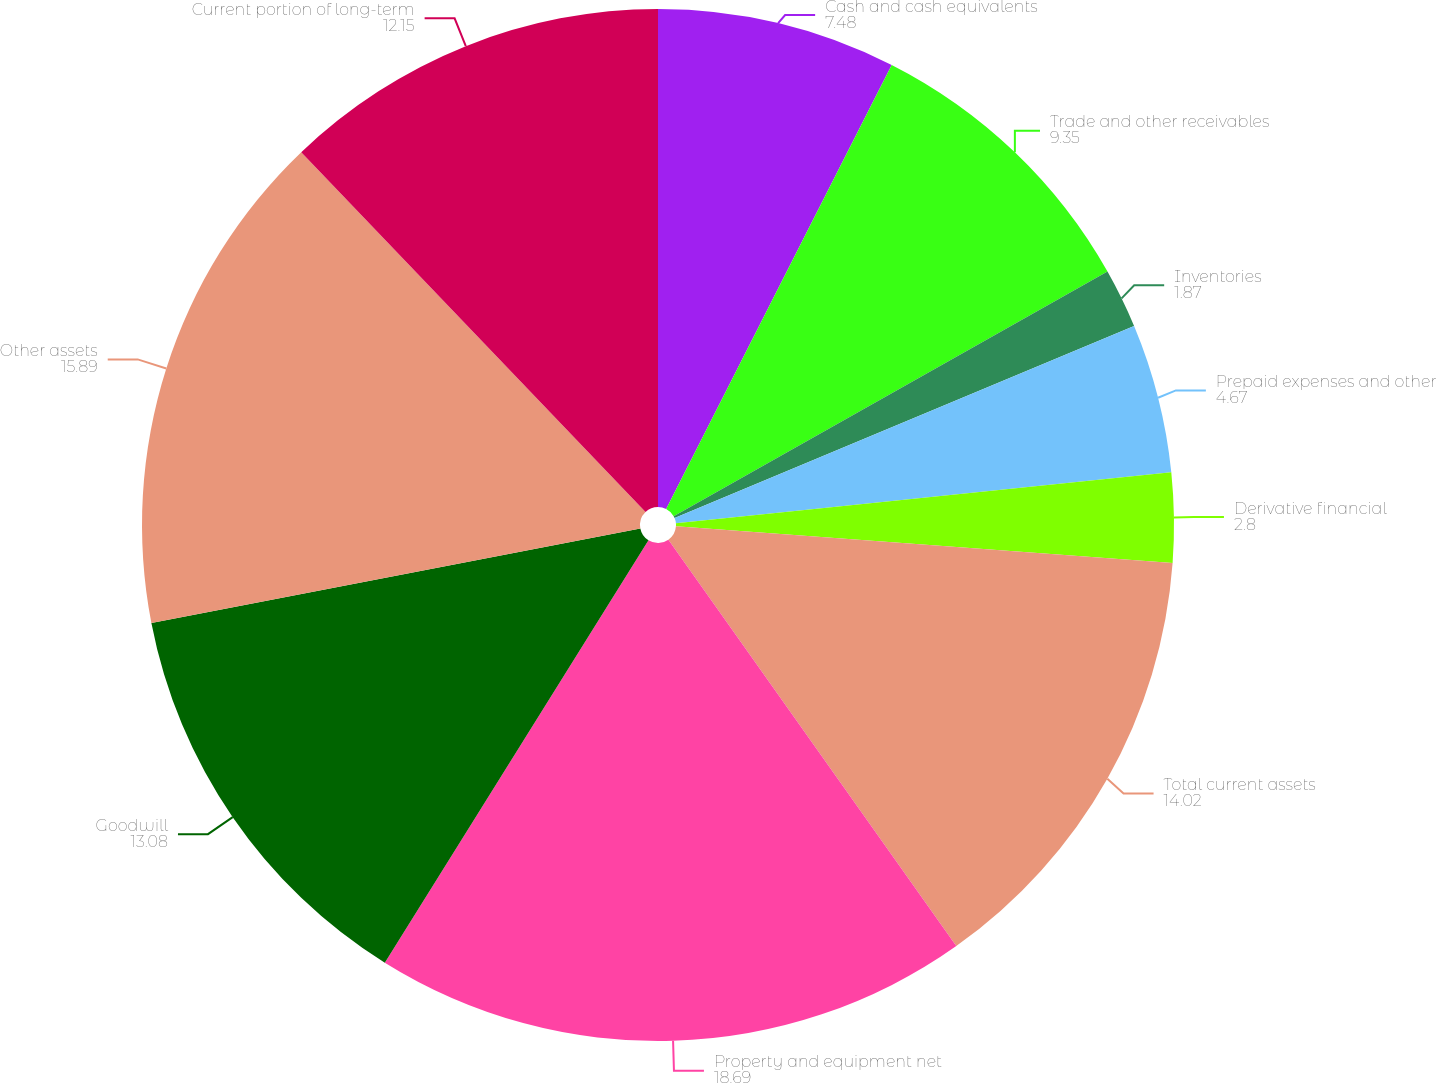Convert chart. <chart><loc_0><loc_0><loc_500><loc_500><pie_chart><fcel>Cash and cash equivalents<fcel>Trade and other receivables<fcel>Inventories<fcel>Prepaid expenses and other<fcel>Derivative financial<fcel>Total current assets<fcel>Property and equipment net<fcel>Goodwill<fcel>Other assets<fcel>Current portion of long-term<nl><fcel>7.48%<fcel>9.35%<fcel>1.87%<fcel>4.67%<fcel>2.8%<fcel>14.02%<fcel>18.69%<fcel>13.08%<fcel>15.89%<fcel>12.15%<nl></chart> 